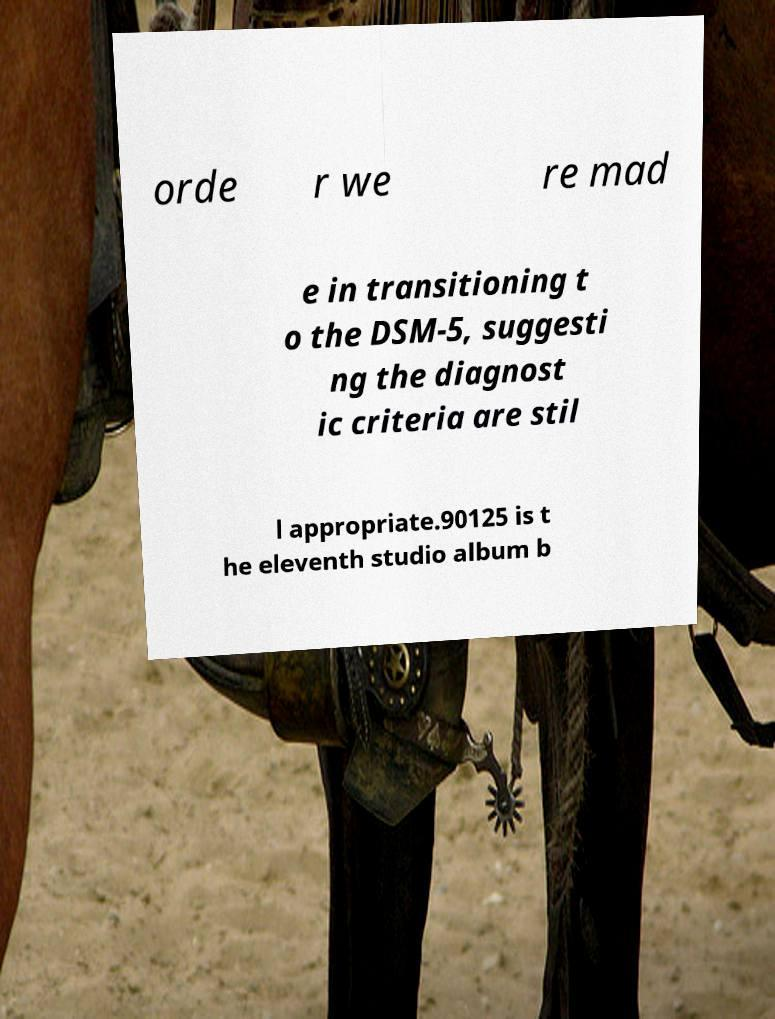Please identify and transcribe the text found in this image. orde r we re mad e in transitioning t o the DSM-5, suggesti ng the diagnost ic criteria are stil l appropriate.90125 is t he eleventh studio album b 